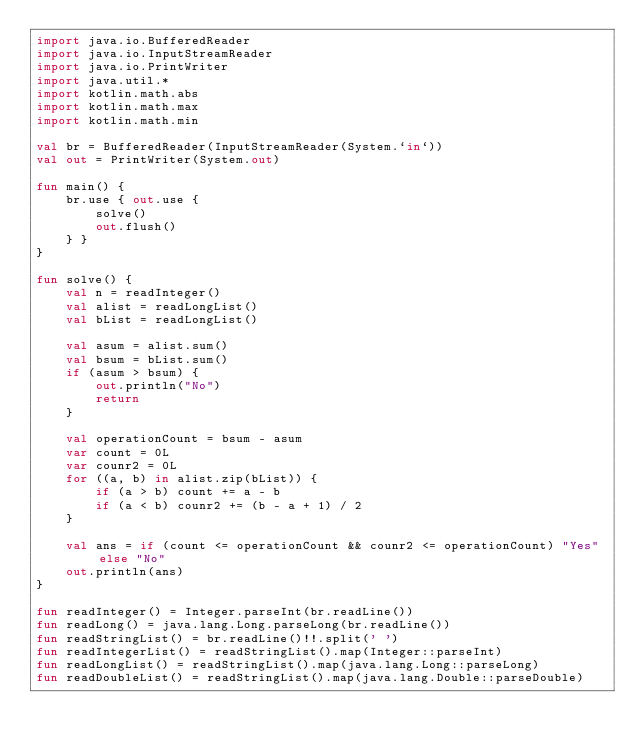Convert code to text. <code><loc_0><loc_0><loc_500><loc_500><_Kotlin_>import java.io.BufferedReader
import java.io.InputStreamReader
import java.io.PrintWriter
import java.util.*
import kotlin.math.abs
import kotlin.math.max
import kotlin.math.min

val br = BufferedReader(InputStreamReader(System.`in`))
val out = PrintWriter(System.out)

fun main() {
    br.use { out.use {
        solve()
        out.flush()
    } }
}

fun solve() {
    val n = readInteger()
    val alist = readLongList()
    val bList = readLongList()

    val asum = alist.sum()
    val bsum = bList.sum()
    if (asum > bsum) {
        out.println("No")
        return
    }

    val operationCount = bsum - asum
    var count = 0L
    var counr2 = 0L
    for ((a, b) in alist.zip(bList)) {
        if (a > b) count += a - b
        if (a < b) counr2 += (b - a + 1) / 2
    }

    val ans = if (count <= operationCount && counr2 <= operationCount) "Yes" else "No"
    out.println(ans)
}

fun readInteger() = Integer.parseInt(br.readLine())
fun readLong() = java.lang.Long.parseLong(br.readLine())
fun readStringList() = br.readLine()!!.split(' ')
fun readIntegerList() = readStringList().map(Integer::parseInt)
fun readLongList() = readStringList().map(java.lang.Long::parseLong)
fun readDoubleList() = readStringList().map(java.lang.Double::parseDouble)
</code> 